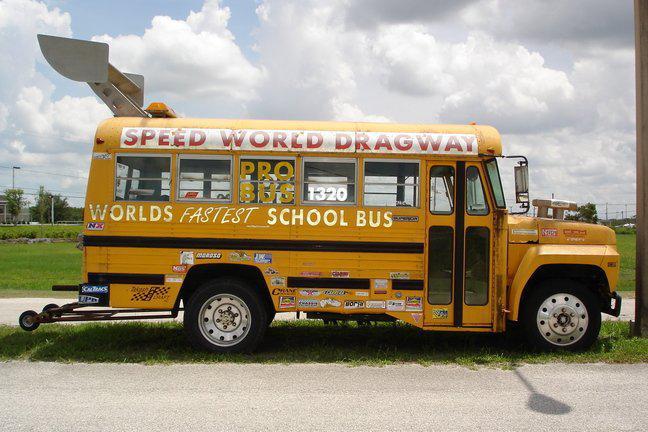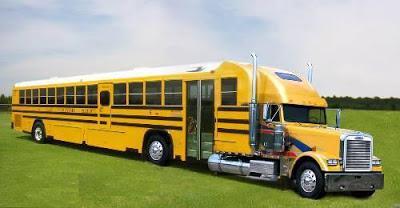The first image is the image on the left, the second image is the image on the right. Analyze the images presented: Is the assertion "The school bus on the left has the hood of a classic car, not of a school bus." valid? Answer yes or no. No. The first image is the image on the left, the second image is the image on the right. Examine the images to the left and right. Is the description "The left image shows a classic-car-look short bus with three passenger windows on a side, a rounded top, and a scooped hood." accurate? Answer yes or no. No. 